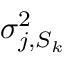Convert formula to latex. <formula><loc_0><loc_0><loc_500><loc_500>\sigma _ { j , S _ { k } } ^ { 2 }</formula> 